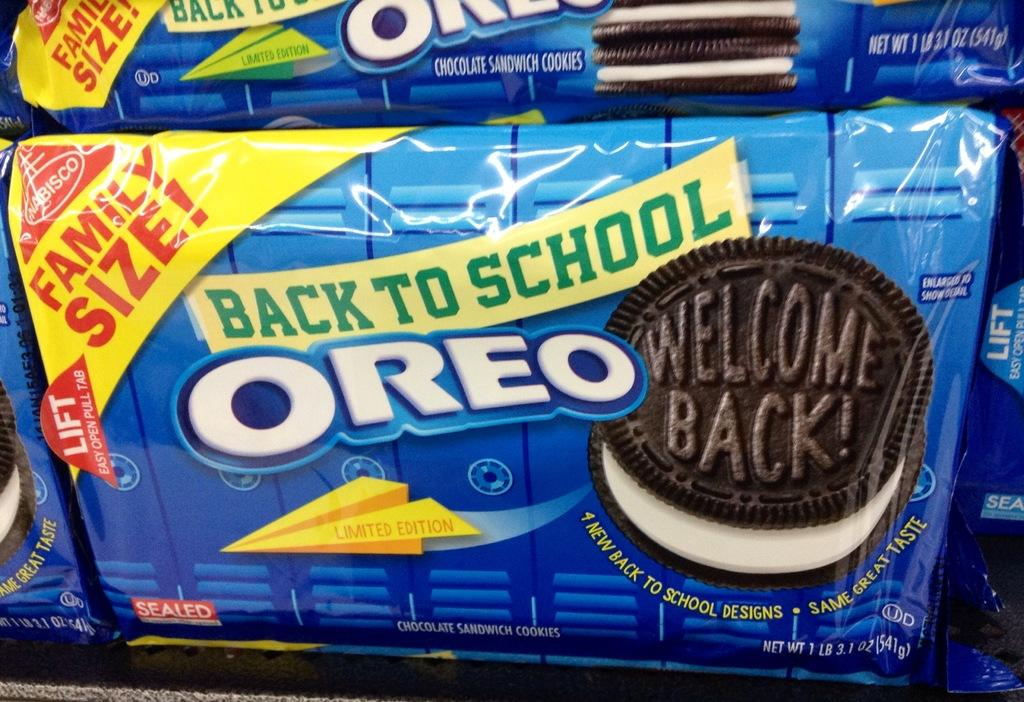<image>
Summarize the visual content of the image. A pack of Oreo's that say back to school 